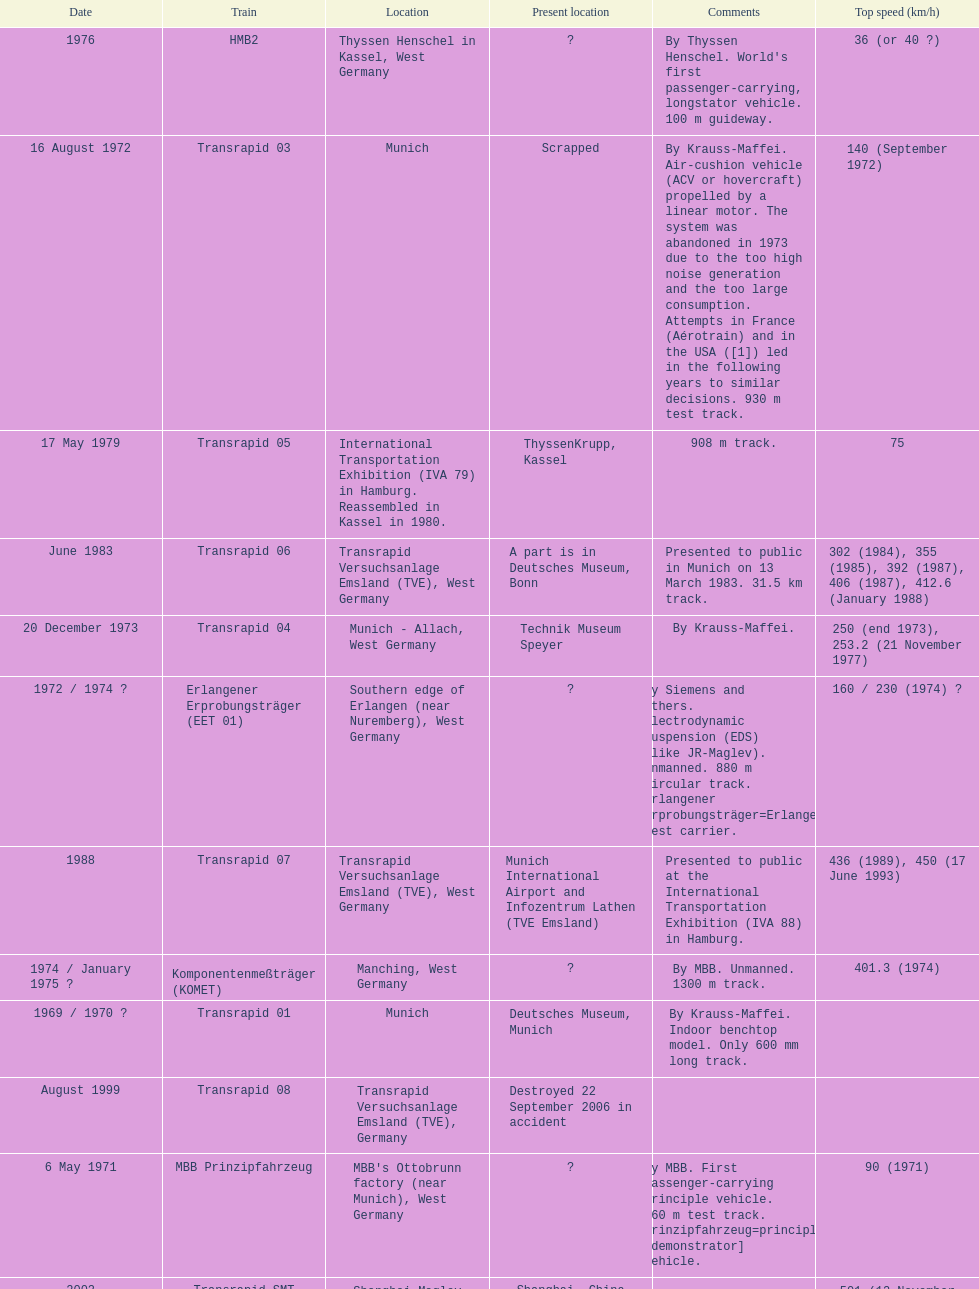Which train has the least top speed? HMB2. Could you help me parse every detail presented in this table? {'header': ['Date', 'Train', 'Location', 'Present location', 'Comments', 'Top speed (km/h)'], 'rows': [['1976', 'HMB2', 'Thyssen Henschel in Kassel, West Germany', '?', "By Thyssen Henschel. World's first passenger-carrying, longstator vehicle. 100 m guideway.", '36 (or 40\xa0?)'], ['16 August 1972', 'Transrapid 03', 'Munich', 'Scrapped', 'By Krauss-Maffei. Air-cushion vehicle (ACV or hovercraft) propelled by a linear motor. The system was abandoned in 1973 due to the too high noise generation and the too large consumption. Attempts in France (Aérotrain) and in the USA ([1]) led in the following years to similar decisions. 930 m test track.', '140 (September 1972)'], ['17 May 1979', 'Transrapid 05', 'International Transportation Exhibition (IVA 79) in Hamburg. Reassembled in Kassel in 1980.', 'ThyssenKrupp, Kassel', '908 m track.', '75'], ['June 1983', 'Transrapid 06', 'Transrapid Versuchsanlage Emsland (TVE), West Germany', 'A part is in Deutsches Museum, Bonn', 'Presented to public in Munich on 13 March 1983. 31.5\xa0km track.', '302 (1984), 355 (1985), 392 (1987), 406 (1987), 412.6 (January 1988)'], ['20 December 1973', 'Transrapid 04', 'Munich - Allach, West Germany', 'Technik Museum Speyer', 'By Krauss-Maffei.', '250 (end 1973), 253.2 (21 November 1977)'], ['1972 / 1974\xa0?', 'Erlangener Erprobungsträger (EET 01)', 'Southern edge of Erlangen (near Nuremberg), West Germany', '?', 'By Siemens and others. Electrodynamic suspension (EDS) (like JR-Maglev). Unmanned. 880 m circular track. Erlangener Erprobungsträger=Erlangen test carrier.', '160 / 230 (1974)\xa0?'], ['1988', 'Transrapid 07', 'Transrapid Versuchsanlage Emsland (TVE), West Germany', 'Munich International Airport and Infozentrum Lathen (TVE Emsland)', 'Presented to public at the International Transportation Exhibition (IVA 88) in Hamburg.', '436 (1989), 450 (17 June 1993)'], ['1974 / January 1975\xa0?', 'Komponentenmeßträger (KOMET)', 'Manching, West Germany', '?', 'By MBB. Unmanned. 1300 m track.', '401.3 (1974)'], ['1969 / 1970\xa0?', 'Transrapid 01', 'Munich', 'Deutsches Museum, Munich', 'By Krauss-Maffei. Indoor benchtop model. Only 600\xa0mm long track.', ''], ['August 1999', 'Transrapid 08', 'Transrapid Versuchsanlage Emsland (TVE), Germany', 'Destroyed 22 September 2006 in accident', '', ''], ['6 May 1971', 'MBB Prinzipfahrzeug', "MBB's Ottobrunn factory (near Munich), West Germany", '?', 'By MBB. First passenger-carrying principle vehicle. 660 m test track. Prinzipfahrzeug=principle [demonstrator] vehicle.', '90 (1971)'], ['2002', 'Transrapid SMT', 'Shanghai Maglev Train, China', 'Shanghai, China', '', '501 (12 November 2003)'], ['2007', 'Transrapid 09', 'Transrapid Versuchsanlage Emsland (TVE), Germany', '?', '', ''], ['6 October 1971', 'Transrapid 02', "Krauss-Maffei's plant in Munich - Allach, West Germany", 'Krauss-Maffei, Munich', 'By Krauss-Maffei. 930 m test track which included one curve. Displayed at Paris Expo from 4 June to 9 June 1973.', '164 (October 1971)'], ['1975', 'HMB1', 'Thyssen Henschel in Kassel, West Germany', '?', 'By Thyssen Henschel. First functional longstator vehicle. 100 m guideway. Unmanned.', '']]} 